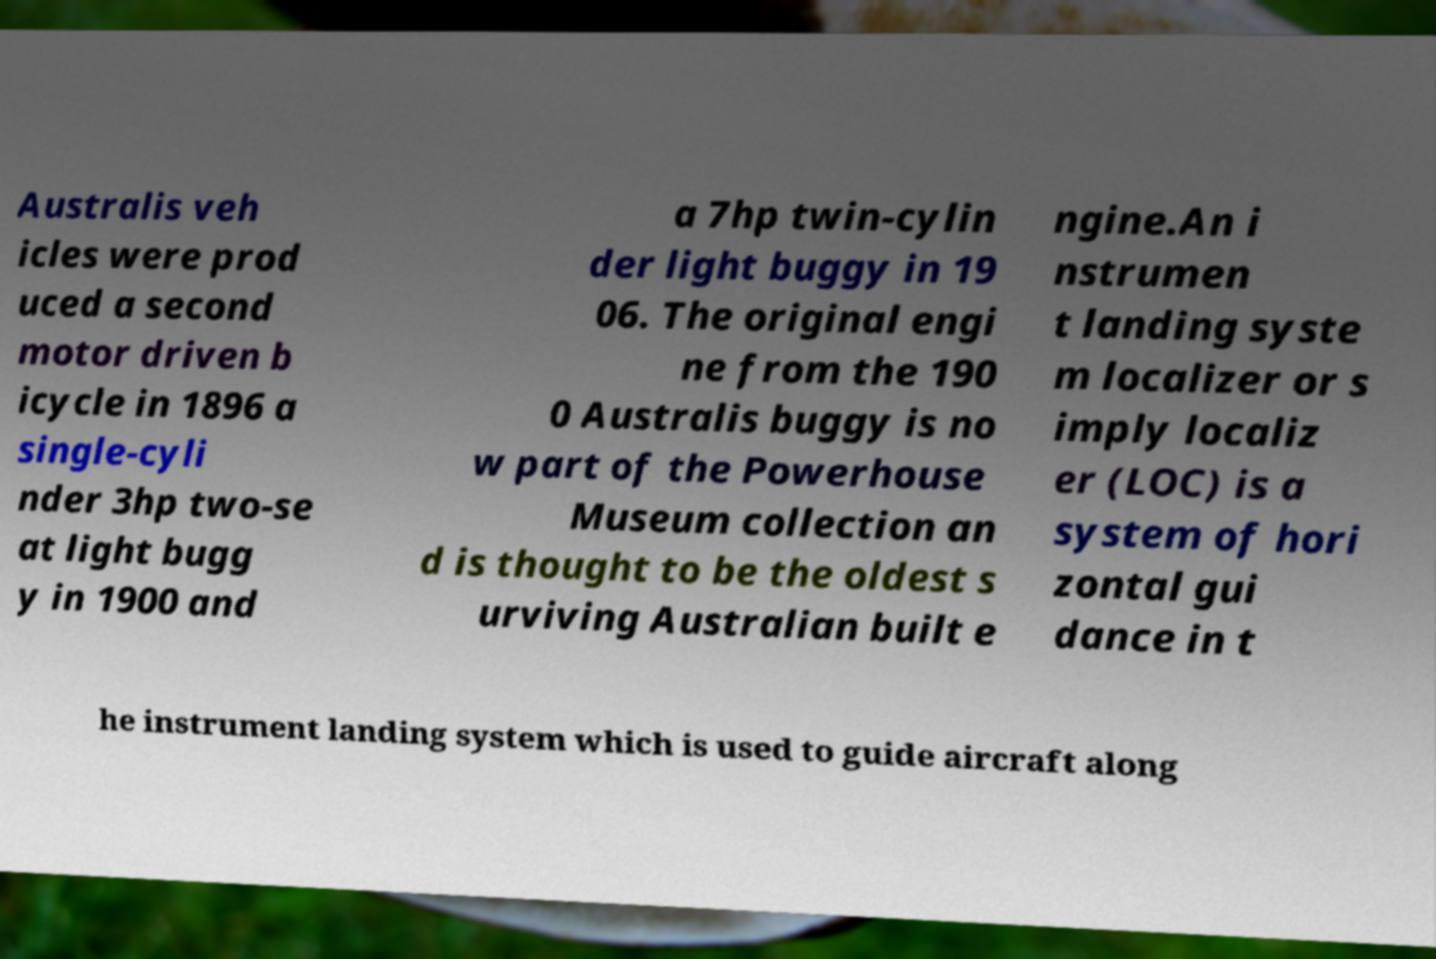For documentation purposes, I need the text within this image transcribed. Could you provide that? Australis veh icles were prod uced a second motor driven b icycle in 1896 a single-cyli nder 3hp two-se at light bugg y in 1900 and a 7hp twin-cylin der light buggy in 19 06. The original engi ne from the 190 0 Australis buggy is no w part of the Powerhouse Museum collection an d is thought to be the oldest s urviving Australian built e ngine.An i nstrumen t landing syste m localizer or s imply localiz er (LOC) is a system of hori zontal gui dance in t he instrument landing system which is used to guide aircraft along 